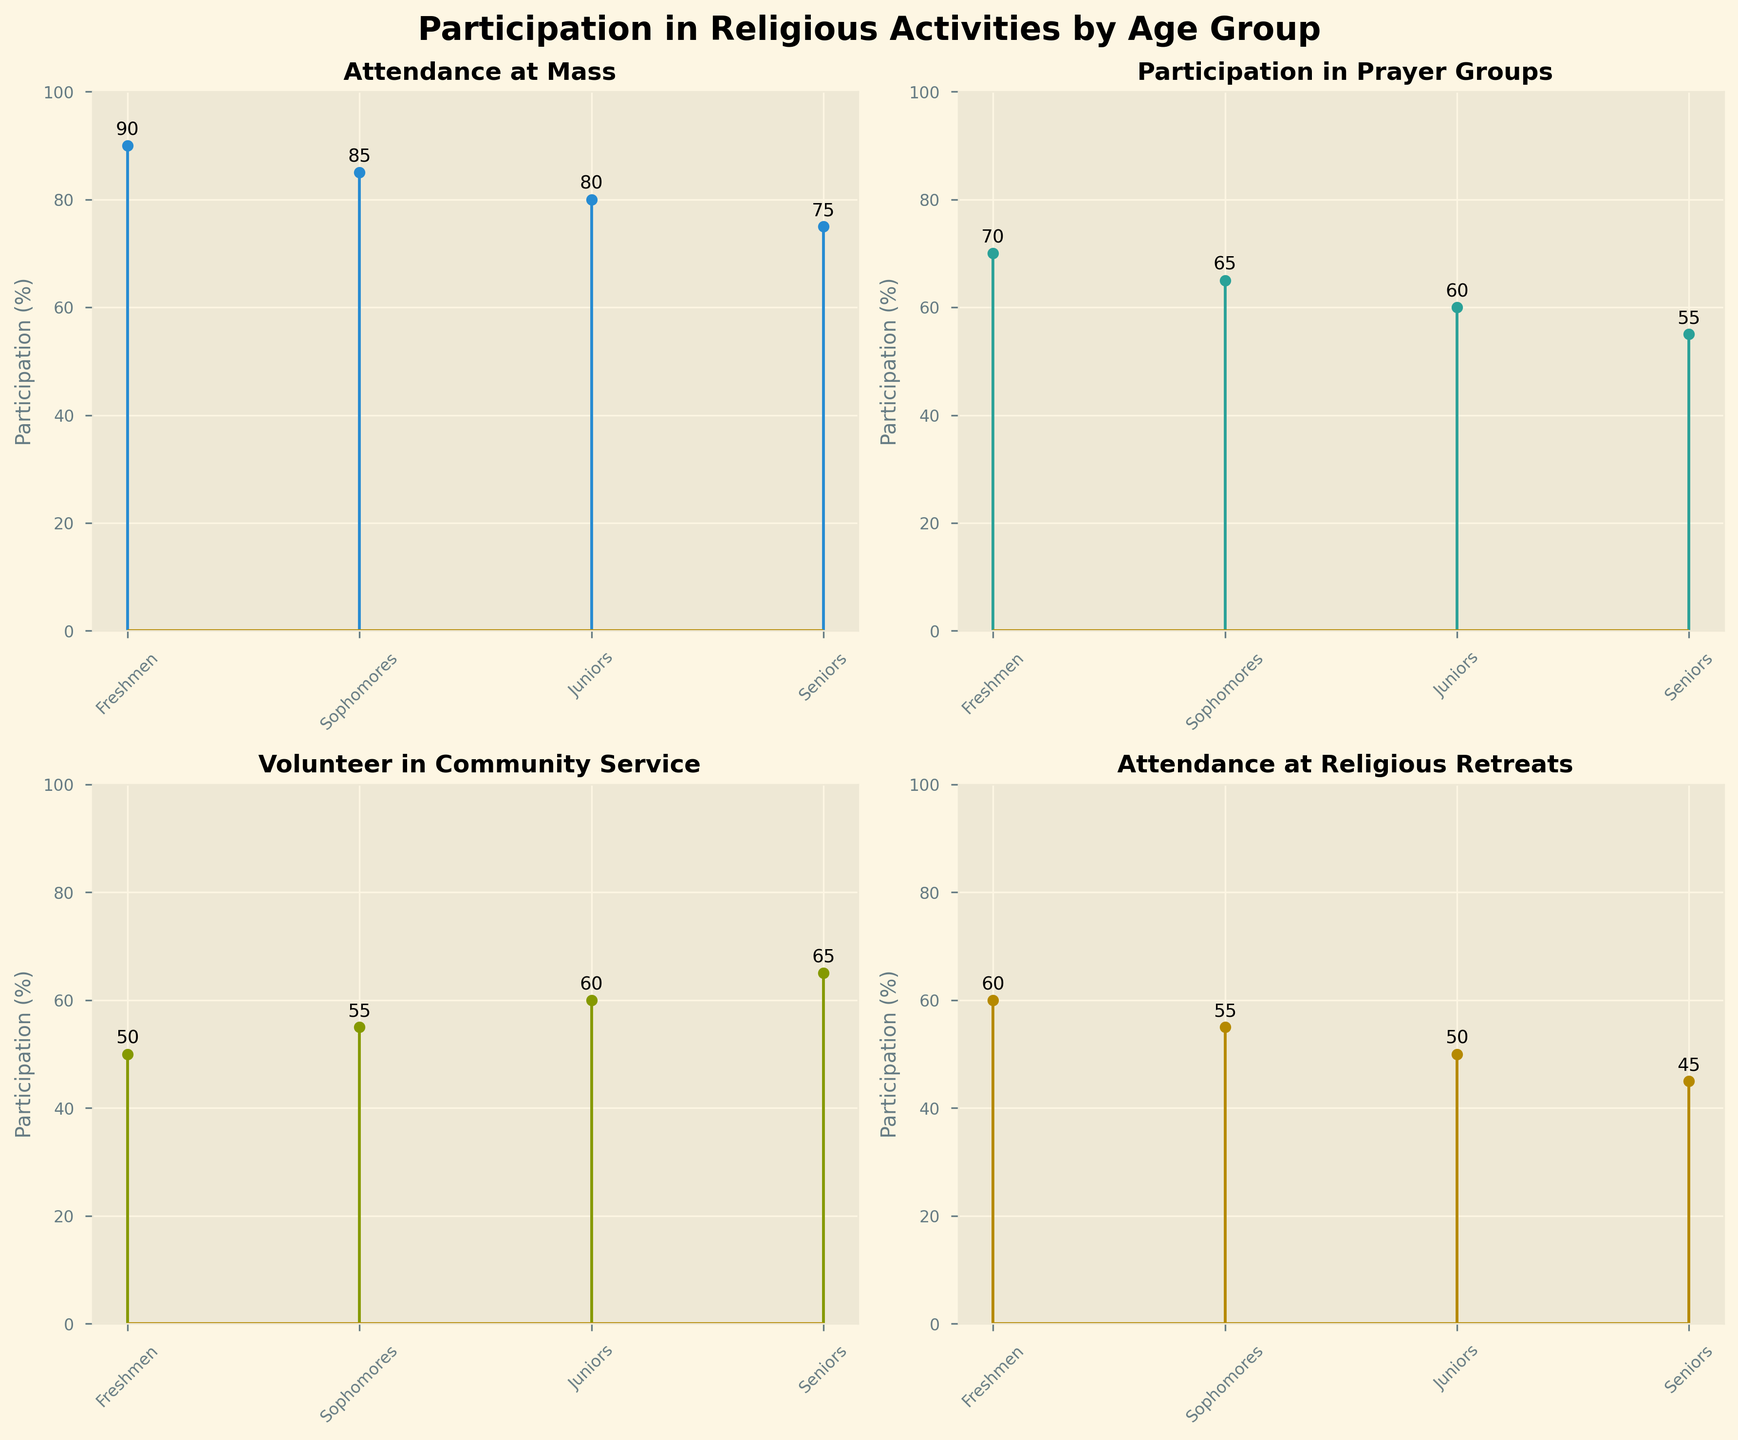What is the title of the figure? The title of the figure is typically located at the top of the plot and provides an overview of what the data represents.
Answer: Participation in Religious Activities by Age Group Which age group has the highest attendance at Mass? Look at the subplot titled "Attendance at Mass" and observe the height of the stem plots for each age group. The tallest stem indicates the highest value.
Answer: Freshmen What is the difference in percentage for community service participation between freshmen and seniors? Identify the data points for "Volunteer in Community Service" for both freshmen (50%) and seniors (65%), then calculate the difference: 65% - 50%.
Answer: 15% Which activity sees the greatest decline in participation from freshmen to seniors? Compare the stem plots for each activity, calculating the difference in participation percentages from freshmen to seniors: Mass (90 to 75), Prayer Groups (70 to 55), Community Service (50 to 65), Retreats (60 to 45). The largest decline will have the highest numerical difference.
Answer: Attendance at Mass How does participation in religious retreats change as students progress through high school? Examine the subplot titled "Attendance at Religious Retreats" and note the trend in the values from freshmen to seniors: 60%, 55%, 50%, 45%.
Answer: It decreases steadily On average, what is the percentage of participation in religious activities for juniors? For juniors, sum the participation percentages for each activity (80, 60, 60, 50) and divide by the number of activities (4): (80 + 60 + 60 + 50) / 4.
Answer: 62.5% Are there any activities where senior participation is greater than freshman participation? Compare the participation rates for freshmen and seniors across all activities: Mass (90 vs 75), Prayer Groups (70 vs 55), Community Service (50 vs 65), Retreats (60 vs 45). Find where the senior value is greater than the freshman value.
Answer: Volunteer in Community Service Which activity has the smallest difference in participation between the age groups? Calculate the differences in participation for each activity from freshmen to seniors: Mass (15), Prayer Groups (15), Community Service (15), Retreats (15). All differences are equal, so there is no smallest difference.
Answer: All activities have equal differences What percentage of sophomores participate in prayer groups? Find the specific data point for sophomores in the subplot "Participation in Prayer Groups".
Answer: 65% What pattern do you observe in the attendance at Mass as students advance from freshmen to seniors? Look at the trend in the "Attendance at Mass" subplot. The values decrease sequentially from 90%, 85%, 80%, to 75%.
Answer: It decreases gradually 